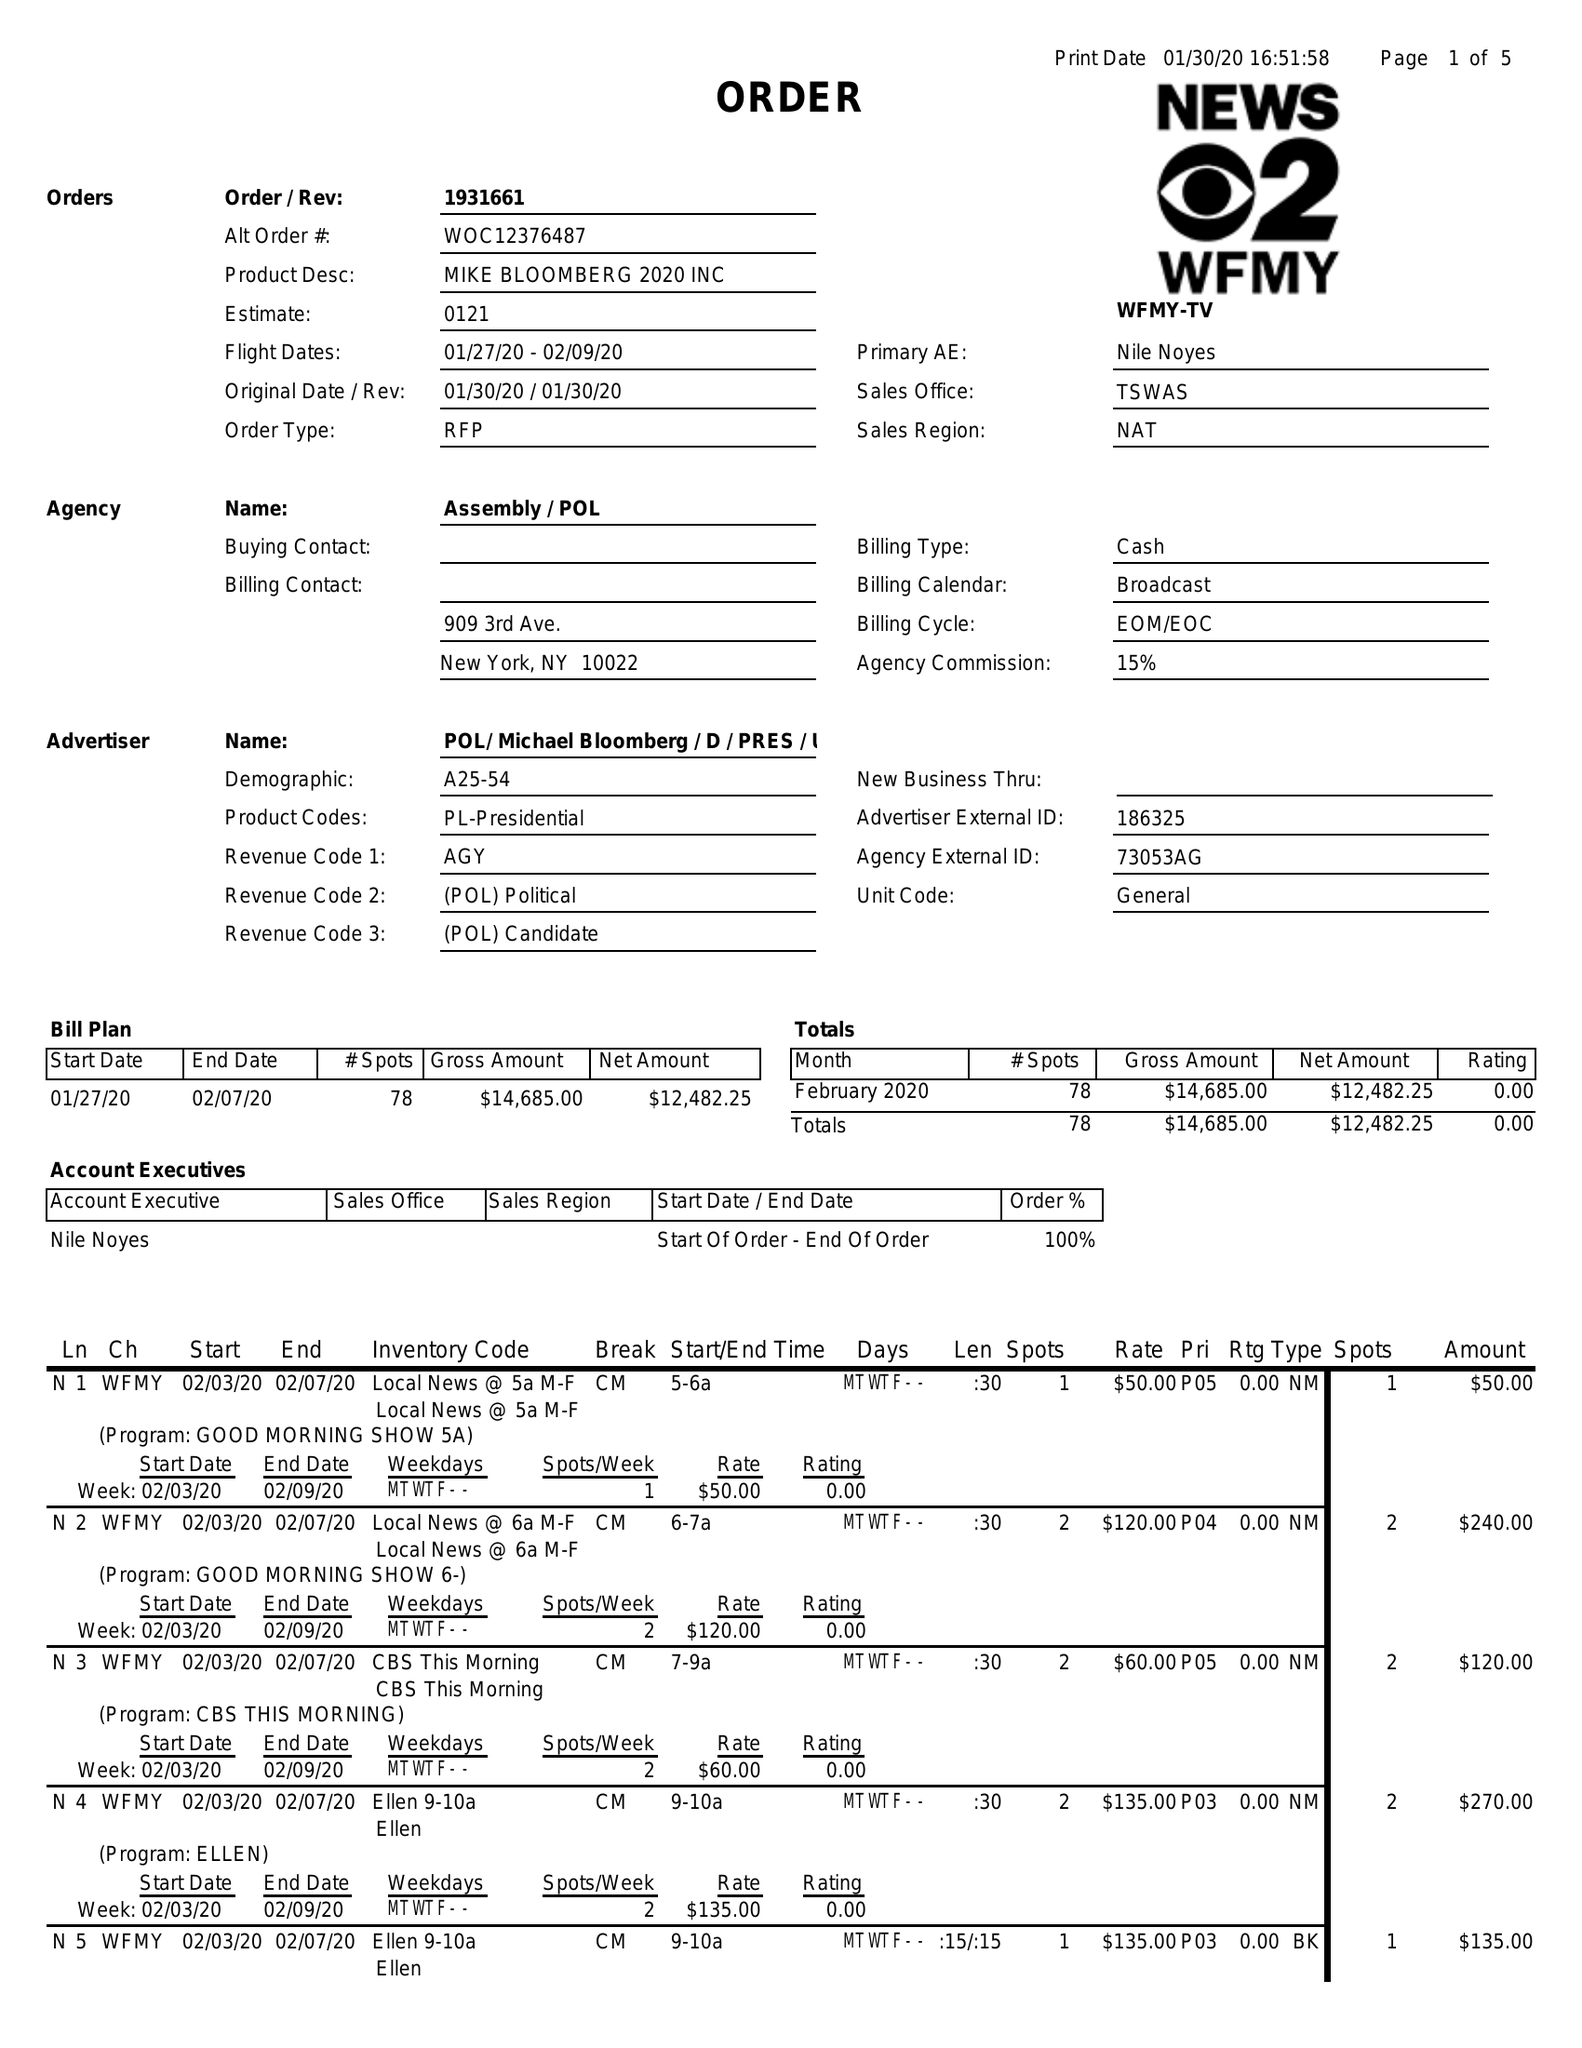What is the value for the advertiser?
Answer the question using a single word or phrase. POL/MICHAELBLOOMBERG/D/PRES/US 